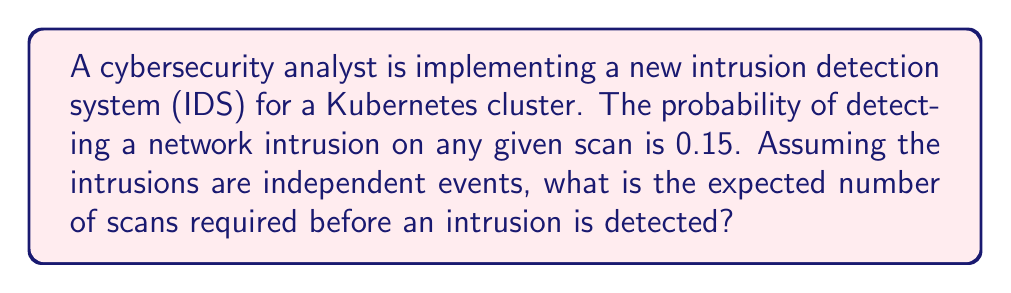Solve this math problem. To solve this problem, we need to recognize that this scenario follows a geometric distribution. The geometric distribution models the number of trials needed to achieve the first success in a series of independent Bernoulli trials.

Let X be the random variable representing the number of scans until an intrusion is detected.

The probability of success (detecting an intrusion) on any given scan is p = 0.15.

For a geometric distribution, the expected value (mean) is given by the formula:

$$ E[X] = \frac{1}{p} $$

Where:
E[X] is the expected value of X
p is the probability of success on each trial

Substituting our value:

$$ E[X] = \frac{1}{0.15} $$

$$ E[X] = 6.67 $$

Therefore, the expected number of scans before detecting an intrusion is approximately 6.67.

This result means that, on average, the cybersecurity analyst would need to perform about 7 scans before detecting a network intrusion in the Kubernetes cluster.
Answer: The expected number of scans required before detecting a network intrusion is $\frac{1}{0.15} \approx 6.67$ scans. 